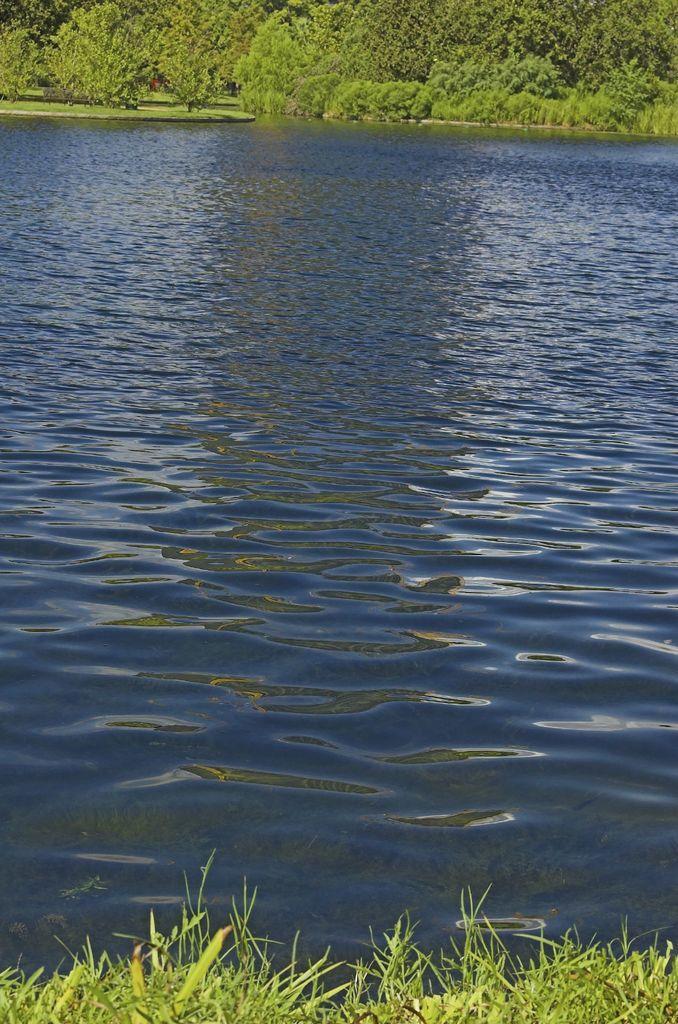Can you describe this image briefly? In this image, I can see water and trees. At the bottom of the image, there is grass. 